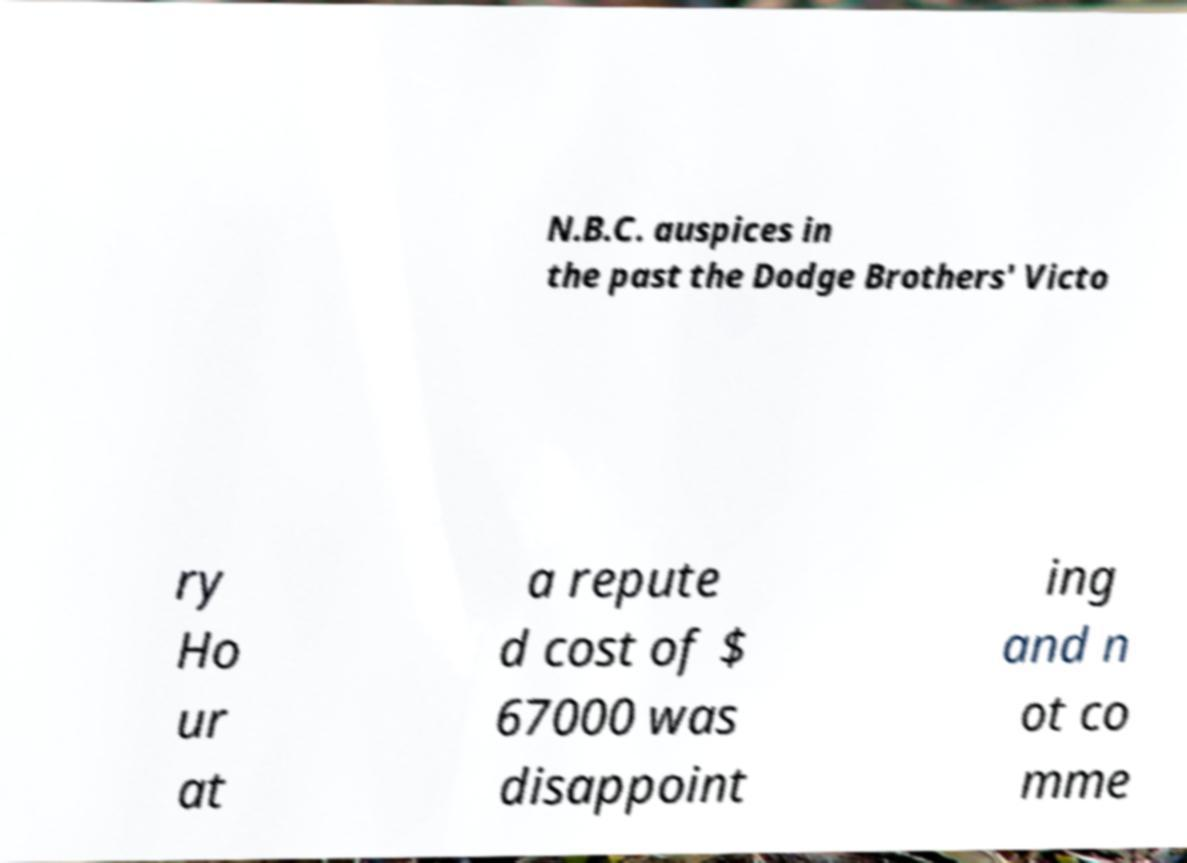For documentation purposes, I need the text within this image transcribed. Could you provide that? N.B.C. auspices in the past the Dodge Brothers' Victo ry Ho ur at a repute d cost of $ 67000 was disappoint ing and n ot co mme 